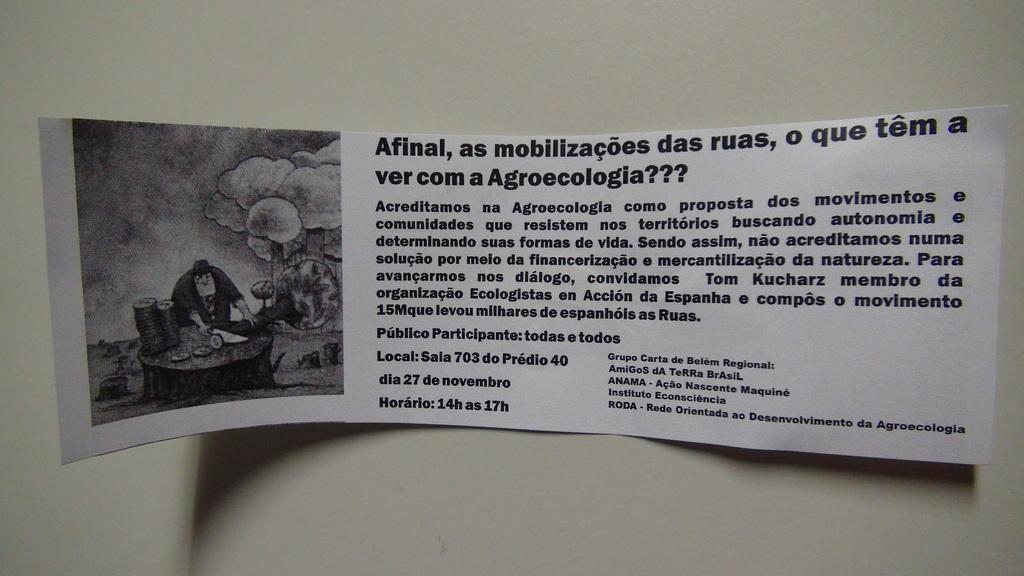Could you give a brief overview of what you see in this image? In this image we can see a poster on the wall. On poster we can see some text and a photo. 